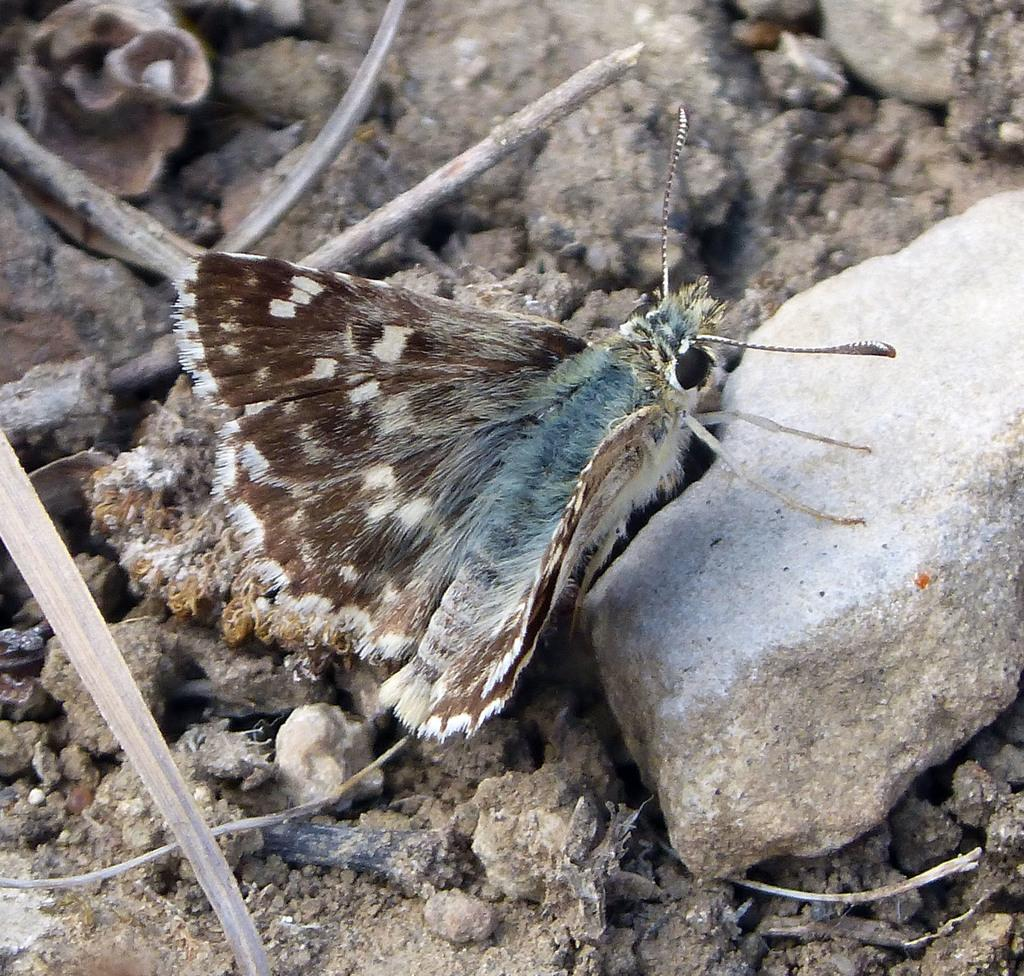What type of animal can be seen in the image? There is a butterfly in the image. What natural elements are present in the image? There are stones and sticks in the image. What is the name of the operation being performed on the butterfly in the image? There is no operation being performed on the butterfly in the image, as it is a photograph of a butterfly in its natural environment. 